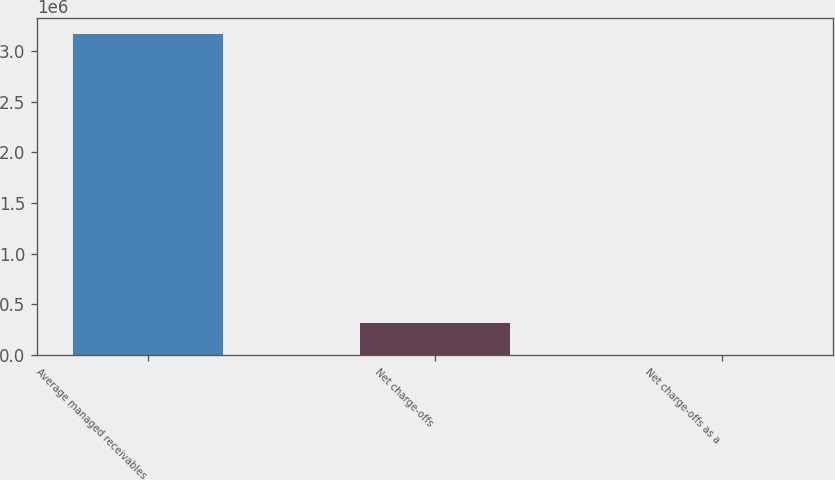Convert chart. <chart><loc_0><loc_0><loc_500><loc_500><bar_chart><fcel>Average managed receivables<fcel>Net charge-offs<fcel>Net charge-offs as a<nl><fcel>3.17048e+06<fcel>317054<fcel>6.5<nl></chart> 